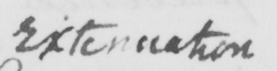What text is written in this handwritten line? Extenuation 